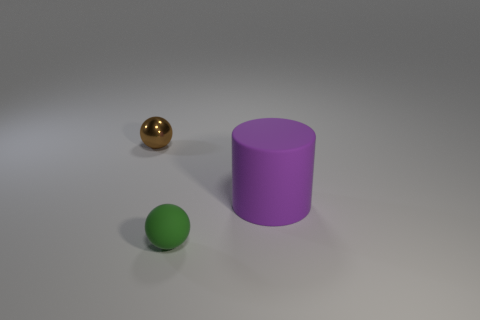What is the color of the other shiny sphere that is the same size as the green sphere?
Give a very brief answer. Brown. Are there any other purple things that have the same shape as the purple rubber object?
Provide a short and direct response. No. Are there fewer big matte cylinders than tiny gray metal blocks?
Give a very brief answer. No. There is a tiny sphere behind the green ball; what color is it?
Provide a short and direct response. Brown. There is a tiny object that is behind the thing that is to the right of the rubber sphere; what is its shape?
Offer a very short reply. Sphere. Do the brown ball and the object to the right of the small green ball have the same material?
Your answer should be compact. No. What number of other metallic objects are the same size as the purple object?
Ensure brevity in your answer.  0. Is the number of big matte cylinders that are behind the green rubber object less than the number of large red rubber objects?
Provide a short and direct response. No. How many brown things are in front of the purple object?
Keep it short and to the point. 0. What size is the purple cylinder that is on the right side of the small brown metal thing that is on the left side of the purple rubber thing right of the tiny brown metal sphere?
Provide a short and direct response. Large. 